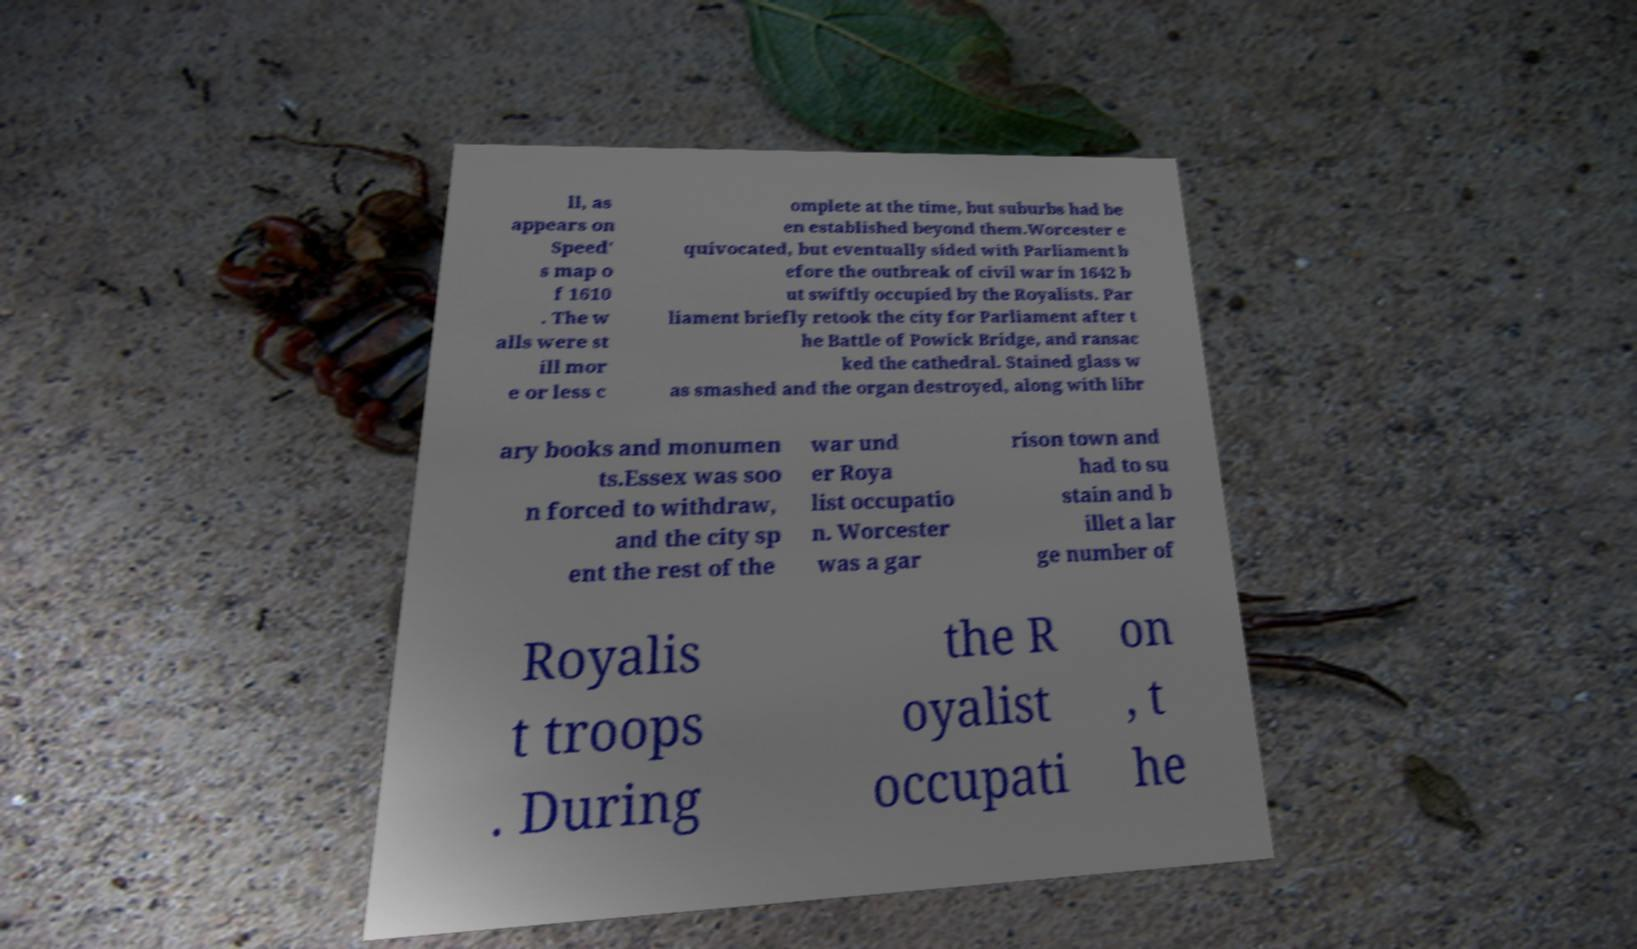I need the written content from this picture converted into text. Can you do that? ll, as appears on Speed' s map o f 1610 . The w alls were st ill mor e or less c omplete at the time, but suburbs had be en established beyond them.Worcester e quivocated, but eventually sided with Parliament b efore the outbreak of civil war in 1642 b ut swiftly occupied by the Royalists. Par liament briefly retook the city for Parliament after t he Battle of Powick Bridge, and ransac ked the cathedral. Stained glass w as smashed and the organ destroyed, along with libr ary books and monumen ts.Essex was soo n forced to withdraw, and the city sp ent the rest of the war und er Roya list occupatio n. Worcester was a gar rison town and had to su stain and b illet a lar ge number of Royalis t troops . During the R oyalist occupati on , t he 